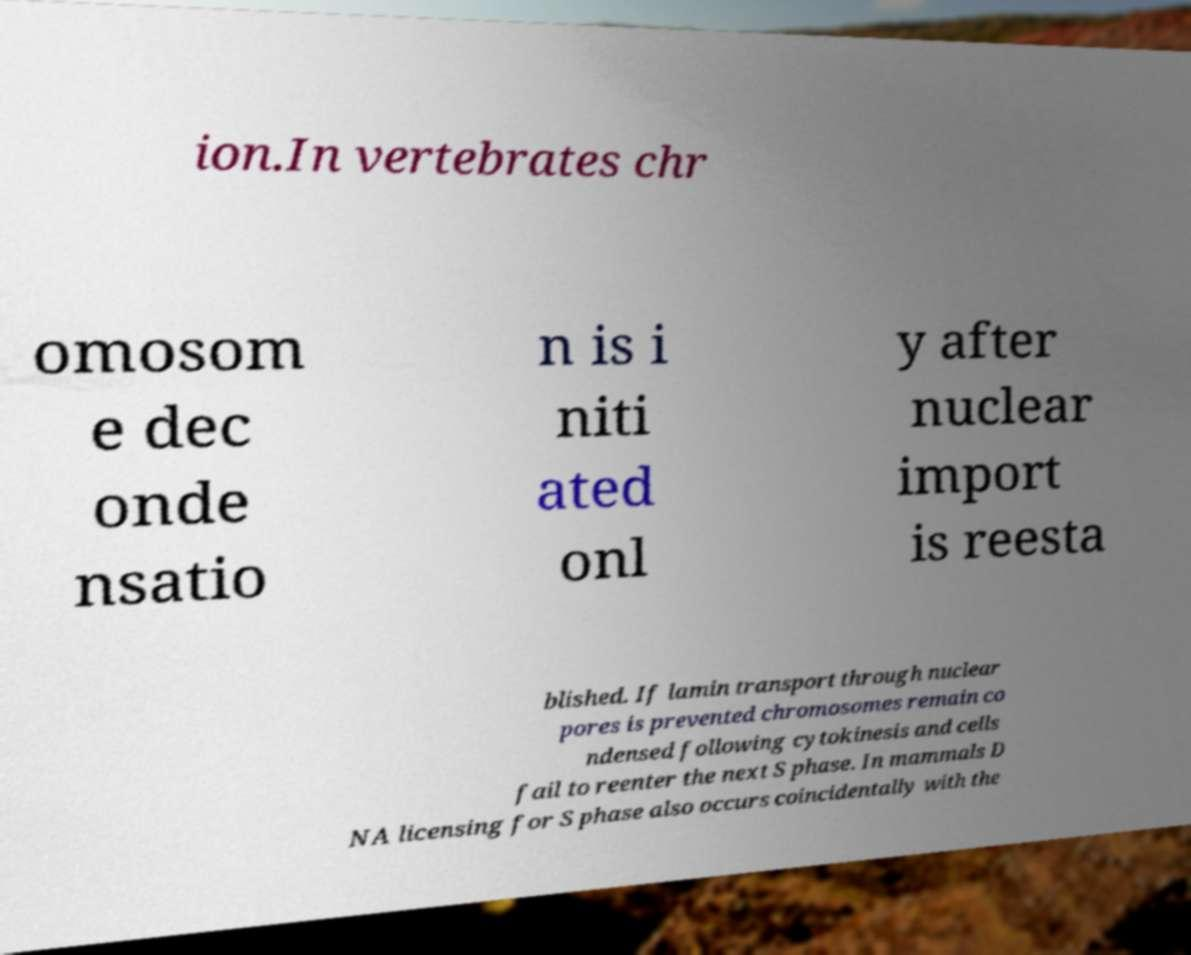I need the written content from this picture converted into text. Can you do that? ion.In vertebrates chr omosom e dec onde nsatio n is i niti ated onl y after nuclear import is reesta blished. If lamin transport through nuclear pores is prevented chromosomes remain co ndensed following cytokinesis and cells fail to reenter the next S phase. In mammals D NA licensing for S phase also occurs coincidentally with the 